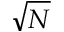Convert formula to latex. <formula><loc_0><loc_0><loc_500><loc_500>\sqrt { N }</formula> 